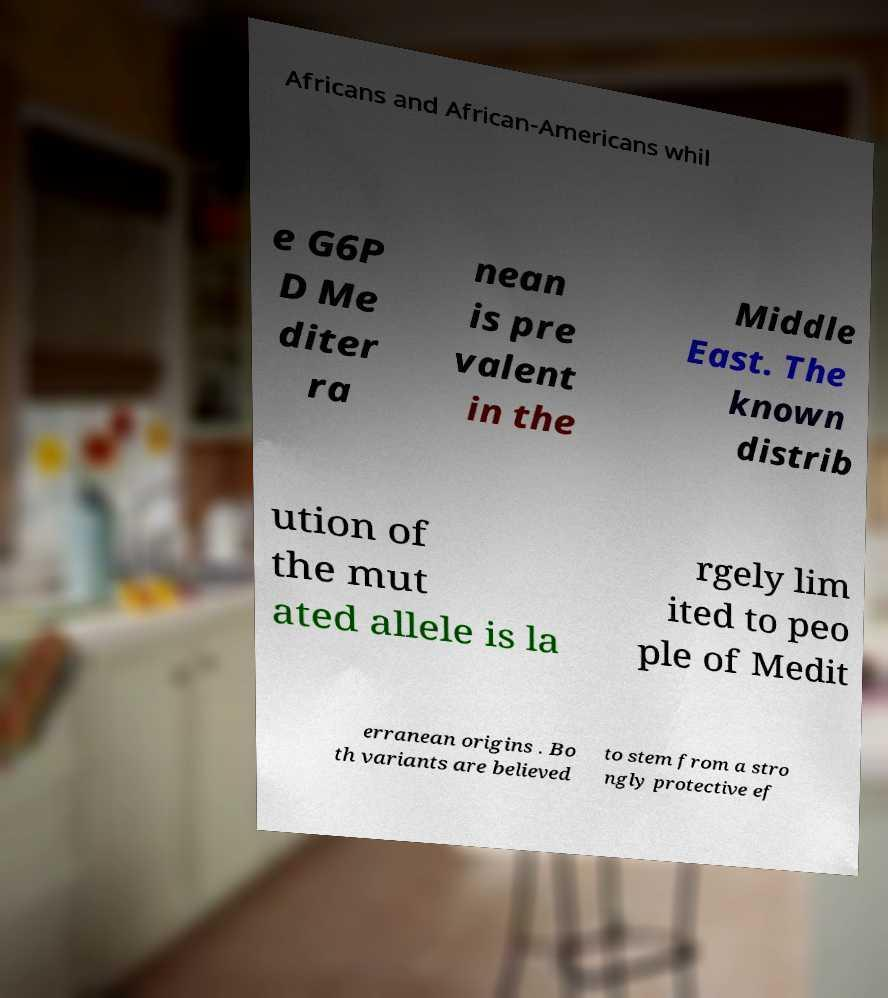Can you accurately transcribe the text from the provided image for me? Africans and African-Americans whil e G6P D Me diter ra nean is pre valent in the Middle East. The known distrib ution of the mut ated allele is la rgely lim ited to peo ple of Medit erranean origins . Bo th variants are believed to stem from a stro ngly protective ef 